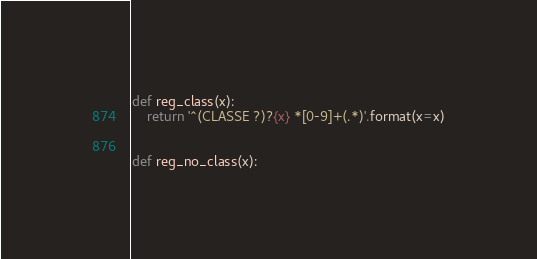Convert code to text. <code><loc_0><loc_0><loc_500><loc_500><_Python_>def reg_class(x):
    return '^(CLASSE ?)?{x} *[0-9]+(.*)'.format(x=x)


def reg_no_class(x):</code> 